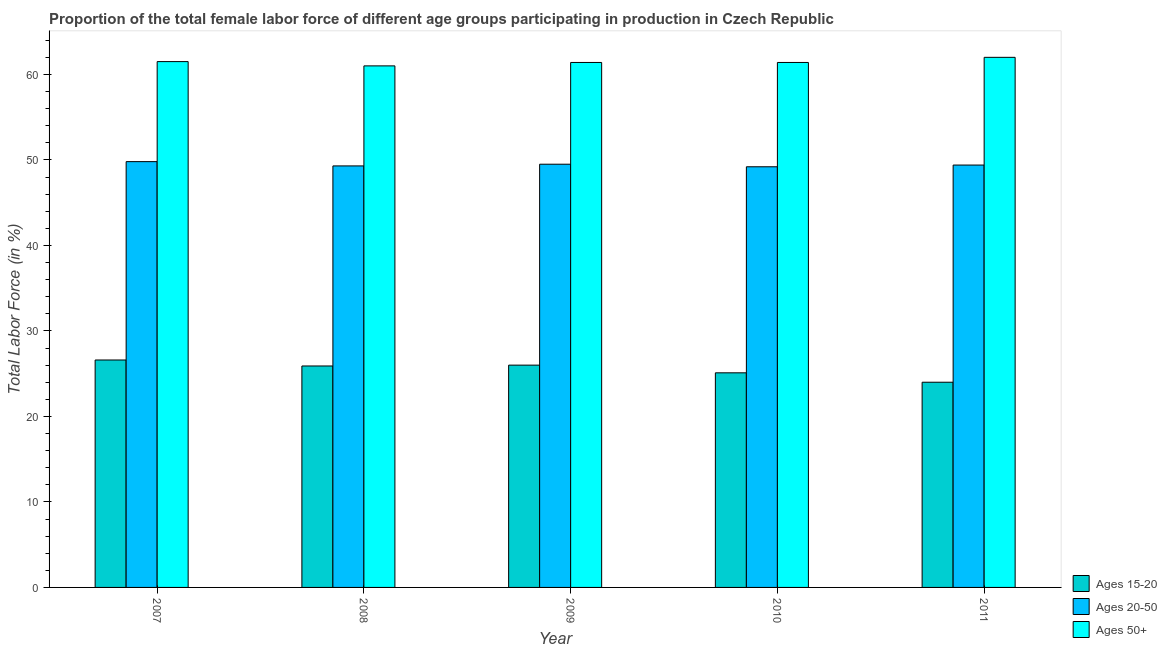How many different coloured bars are there?
Your response must be concise. 3. Are the number of bars per tick equal to the number of legend labels?
Ensure brevity in your answer.  Yes. What is the percentage of female labor force above age 50 in 2010?
Ensure brevity in your answer.  61.4. Across all years, what is the maximum percentage of female labor force above age 50?
Make the answer very short. 62. Across all years, what is the minimum percentage of female labor force above age 50?
Your answer should be very brief. 61. In which year was the percentage of female labor force within the age group 20-50 minimum?
Keep it short and to the point. 2010. What is the total percentage of female labor force within the age group 15-20 in the graph?
Provide a succinct answer. 127.6. What is the difference between the percentage of female labor force within the age group 20-50 in 2007 and the percentage of female labor force within the age group 15-20 in 2010?
Make the answer very short. 0.6. What is the average percentage of female labor force within the age group 15-20 per year?
Give a very brief answer. 25.52. In the year 2008, what is the difference between the percentage of female labor force within the age group 15-20 and percentage of female labor force within the age group 20-50?
Ensure brevity in your answer.  0. What is the ratio of the percentage of female labor force within the age group 15-20 in 2010 to that in 2011?
Make the answer very short. 1.05. Is the percentage of female labor force within the age group 15-20 in 2009 less than that in 2011?
Provide a short and direct response. No. What is the difference between the highest and the second highest percentage of female labor force within the age group 15-20?
Your answer should be very brief. 0.6. What is the difference between the highest and the lowest percentage of female labor force above age 50?
Provide a succinct answer. 1. In how many years, is the percentage of female labor force within the age group 15-20 greater than the average percentage of female labor force within the age group 15-20 taken over all years?
Give a very brief answer. 3. What does the 2nd bar from the left in 2008 represents?
Your answer should be compact. Ages 20-50. What does the 1st bar from the right in 2008 represents?
Offer a very short reply. Ages 50+. Is it the case that in every year, the sum of the percentage of female labor force within the age group 15-20 and percentage of female labor force within the age group 20-50 is greater than the percentage of female labor force above age 50?
Provide a succinct answer. Yes. How many bars are there?
Ensure brevity in your answer.  15. How are the legend labels stacked?
Your answer should be compact. Vertical. What is the title of the graph?
Your answer should be very brief. Proportion of the total female labor force of different age groups participating in production in Czech Republic. What is the label or title of the X-axis?
Make the answer very short. Year. What is the label or title of the Y-axis?
Offer a terse response. Total Labor Force (in %). What is the Total Labor Force (in %) in Ages 15-20 in 2007?
Provide a short and direct response. 26.6. What is the Total Labor Force (in %) of Ages 20-50 in 2007?
Your answer should be compact. 49.8. What is the Total Labor Force (in %) of Ages 50+ in 2007?
Offer a terse response. 61.5. What is the Total Labor Force (in %) of Ages 15-20 in 2008?
Offer a terse response. 25.9. What is the Total Labor Force (in %) of Ages 20-50 in 2008?
Your answer should be compact. 49.3. What is the Total Labor Force (in %) in Ages 15-20 in 2009?
Give a very brief answer. 26. What is the Total Labor Force (in %) of Ages 20-50 in 2009?
Offer a terse response. 49.5. What is the Total Labor Force (in %) in Ages 50+ in 2009?
Provide a succinct answer. 61.4. What is the Total Labor Force (in %) in Ages 15-20 in 2010?
Make the answer very short. 25.1. What is the Total Labor Force (in %) in Ages 20-50 in 2010?
Give a very brief answer. 49.2. What is the Total Labor Force (in %) of Ages 50+ in 2010?
Provide a short and direct response. 61.4. What is the Total Labor Force (in %) in Ages 15-20 in 2011?
Make the answer very short. 24. What is the Total Labor Force (in %) in Ages 20-50 in 2011?
Your answer should be compact. 49.4. What is the Total Labor Force (in %) in Ages 50+ in 2011?
Provide a short and direct response. 62. Across all years, what is the maximum Total Labor Force (in %) in Ages 15-20?
Make the answer very short. 26.6. Across all years, what is the maximum Total Labor Force (in %) in Ages 20-50?
Your answer should be very brief. 49.8. Across all years, what is the maximum Total Labor Force (in %) in Ages 50+?
Offer a terse response. 62. Across all years, what is the minimum Total Labor Force (in %) in Ages 15-20?
Keep it short and to the point. 24. Across all years, what is the minimum Total Labor Force (in %) in Ages 20-50?
Keep it short and to the point. 49.2. What is the total Total Labor Force (in %) of Ages 15-20 in the graph?
Keep it short and to the point. 127.6. What is the total Total Labor Force (in %) in Ages 20-50 in the graph?
Give a very brief answer. 247.2. What is the total Total Labor Force (in %) of Ages 50+ in the graph?
Your answer should be compact. 307.3. What is the difference between the Total Labor Force (in %) of Ages 15-20 in 2007 and that in 2008?
Provide a succinct answer. 0.7. What is the difference between the Total Labor Force (in %) of Ages 15-20 in 2007 and that in 2009?
Make the answer very short. 0.6. What is the difference between the Total Labor Force (in %) of Ages 15-20 in 2007 and that in 2010?
Your response must be concise. 1.5. What is the difference between the Total Labor Force (in %) of Ages 20-50 in 2007 and that in 2010?
Keep it short and to the point. 0.6. What is the difference between the Total Labor Force (in %) of Ages 50+ in 2007 and that in 2010?
Provide a succinct answer. 0.1. What is the difference between the Total Labor Force (in %) of Ages 50+ in 2008 and that in 2009?
Provide a succinct answer. -0.4. What is the difference between the Total Labor Force (in %) in Ages 50+ in 2008 and that in 2011?
Your response must be concise. -1. What is the difference between the Total Labor Force (in %) of Ages 15-20 in 2009 and that in 2010?
Provide a short and direct response. 0.9. What is the difference between the Total Labor Force (in %) of Ages 50+ in 2009 and that in 2010?
Your answer should be compact. 0. What is the difference between the Total Labor Force (in %) of Ages 20-50 in 2009 and that in 2011?
Your answer should be compact. 0.1. What is the difference between the Total Labor Force (in %) in Ages 50+ in 2009 and that in 2011?
Offer a terse response. -0.6. What is the difference between the Total Labor Force (in %) of Ages 15-20 in 2007 and the Total Labor Force (in %) of Ages 20-50 in 2008?
Give a very brief answer. -22.7. What is the difference between the Total Labor Force (in %) of Ages 15-20 in 2007 and the Total Labor Force (in %) of Ages 50+ in 2008?
Your answer should be very brief. -34.4. What is the difference between the Total Labor Force (in %) of Ages 15-20 in 2007 and the Total Labor Force (in %) of Ages 20-50 in 2009?
Ensure brevity in your answer.  -22.9. What is the difference between the Total Labor Force (in %) of Ages 15-20 in 2007 and the Total Labor Force (in %) of Ages 50+ in 2009?
Your answer should be compact. -34.8. What is the difference between the Total Labor Force (in %) of Ages 20-50 in 2007 and the Total Labor Force (in %) of Ages 50+ in 2009?
Keep it short and to the point. -11.6. What is the difference between the Total Labor Force (in %) in Ages 15-20 in 2007 and the Total Labor Force (in %) in Ages 20-50 in 2010?
Your response must be concise. -22.6. What is the difference between the Total Labor Force (in %) of Ages 15-20 in 2007 and the Total Labor Force (in %) of Ages 50+ in 2010?
Your answer should be very brief. -34.8. What is the difference between the Total Labor Force (in %) of Ages 20-50 in 2007 and the Total Labor Force (in %) of Ages 50+ in 2010?
Your response must be concise. -11.6. What is the difference between the Total Labor Force (in %) of Ages 15-20 in 2007 and the Total Labor Force (in %) of Ages 20-50 in 2011?
Your answer should be compact. -22.8. What is the difference between the Total Labor Force (in %) of Ages 15-20 in 2007 and the Total Labor Force (in %) of Ages 50+ in 2011?
Your answer should be compact. -35.4. What is the difference between the Total Labor Force (in %) in Ages 20-50 in 2007 and the Total Labor Force (in %) in Ages 50+ in 2011?
Your answer should be compact. -12.2. What is the difference between the Total Labor Force (in %) in Ages 15-20 in 2008 and the Total Labor Force (in %) in Ages 20-50 in 2009?
Your answer should be compact. -23.6. What is the difference between the Total Labor Force (in %) in Ages 15-20 in 2008 and the Total Labor Force (in %) in Ages 50+ in 2009?
Ensure brevity in your answer.  -35.5. What is the difference between the Total Labor Force (in %) in Ages 15-20 in 2008 and the Total Labor Force (in %) in Ages 20-50 in 2010?
Provide a succinct answer. -23.3. What is the difference between the Total Labor Force (in %) of Ages 15-20 in 2008 and the Total Labor Force (in %) of Ages 50+ in 2010?
Provide a short and direct response. -35.5. What is the difference between the Total Labor Force (in %) of Ages 15-20 in 2008 and the Total Labor Force (in %) of Ages 20-50 in 2011?
Your answer should be compact. -23.5. What is the difference between the Total Labor Force (in %) of Ages 15-20 in 2008 and the Total Labor Force (in %) of Ages 50+ in 2011?
Ensure brevity in your answer.  -36.1. What is the difference between the Total Labor Force (in %) of Ages 15-20 in 2009 and the Total Labor Force (in %) of Ages 20-50 in 2010?
Offer a terse response. -23.2. What is the difference between the Total Labor Force (in %) of Ages 15-20 in 2009 and the Total Labor Force (in %) of Ages 50+ in 2010?
Ensure brevity in your answer.  -35.4. What is the difference between the Total Labor Force (in %) in Ages 20-50 in 2009 and the Total Labor Force (in %) in Ages 50+ in 2010?
Offer a very short reply. -11.9. What is the difference between the Total Labor Force (in %) in Ages 15-20 in 2009 and the Total Labor Force (in %) in Ages 20-50 in 2011?
Your answer should be compact. -23.4. What is the difference between the Total Labor Force (in %) in Ages 15-20 in 2009 and the Total Labor Force (in %) in Ages 50+ in 2011?
Offer a terse response. -36. What is the difference between the Total Labor Force (in %) in Ages 15-20 in 2010 and the Total Labor Force (in %) in Ages 20-50 in 2011?
Make the answer very short. -24.3. What is the difference between the Total Labor Force (in %) of Ages 15-20 in 2010 and the Total Labor Force (in %) of Ages 50+ in 2011?
Give a very brief answer. -36.9. What is the average Total Labor Force (in %) of Ages 15-20 per year?
Ensure brevity in your answer.  25.52. What is the average Total Labor Force (in %) in Ages 20-50 per year?
Your response must be concise. 49.44. What is the average Total Labor Force (in %) of Ages 50+ per year?
Your answer should be very brief. 61.46. In the year 2007, what is the difference between the Total Labor Force (in %) in Ages 15-20 and Total Labor Force (in %) in Ages 20-50?
Offer a very short reply. -23.2. In the year 2007, what is the difference between the Total Labor Force (in %) of Ages 15-20 and Total Labor Force (in %) of Ages 50+?
Offer a very short reply. -34.9. In the year 2007, what is the difference between the Total Labor Force (in %) of Ages 20-50 and Total Labor Force (in %) of Ages 50+?
Make the answer very short. -11.7. In the year 2008, what is the difference between the Total Labor Force (in %) in Ages 15-20 and Total Labor Force (in %) in Ages 20-50?
Provide a short and direct response. -23.4. In the year 2008, what is the difference between the Total Labor Force (in %) of Ages 15-20 and Total Labor Force (in %) of Ages 50+?
Your response must be concise. -35.1. In the year 2009, what is the difference between the Total Labor Force (in %) in Ages 15-20 and Total Labor Force (in %) in Ages 20-50?
Your answer should be compact. -23.5. In the year 2009, what is the difference between the Total Labor Force (in %) in Ages 15-20 and Total Labor Force (in %) in Ages 50+?
Offer a very short reply. -35.4. In the year 2009, what is the difference between the Total Labor Force (in %) of Ages 20-50 and Total Labor Force (in %) of Ages 50+?
Your response must be concise. -11.9. In the year 2010, what is the difference between the Total Labor Force (in %) in Ages 15-20 and Total Labor Force (in %) in Ages 20-50?
Your answer should be very brief. -24.1. In the year 2010, what is the difference between the Total Labor Force (in %) of Ages 15-20 and Total Labor Force (in %) of Ages 50+?
Your answer should be compact. -36.3. In the year 2010, what is the difference between the Total Labor Force (in %) of Ages 20-50 and Total Labor Force (in %) of Ages 50+?
Keep it short and to the point. -12.2. In the year 2011, what is the difference between the Total Labor Force (in %) of Ages 15-20 and Total Labor Force (in %) of Ages 20-50?
Keep it short and to the point. -25.4. In the year 2011, what is the difference between the Total Labor Force (in %) of Ages 15-20 and Total Labor Force (in %) of Ages 50+?
Provide a succinct answer. -38. What is the ratio of the Total Labor Force (in %) in Ages 50+ in 2007 to that in 2008?
Offer a very short reply. 1.01. What is the ratio of the Total Labor Force (in %) in Ages 15-20 in 2007 to that in 2009?
Provide a short and direct response. 1.02. What is the ratio of the Total Labor Force (in %) of Ages 20-50 in 2007 to that in 2009?
Provide a succinct answer. 1.01. What is the ratio of the Total Labor Force (in %) in Ages 50+ in 2007 to that in 2009?
Your response must be concise. 1. What is the ratio of the Total Labor Force (in %) of Ages 15-20 in 2007 to that in 2010?
Give a very brief answer. 1.06. What is the ratio of the Total Labor Force (in %) of Ages 20-50 in 2007 to that in 2010?
Your answer should be compact. 1.01. What is the ratio of the Total Labor Force (in %) in Ages 50+ in 2007 to that in 2010?
Ensure brevity in your answer.  1. What is the ratio of the Total Labor Force (in %) of Ages 15-20 in 2007 to that in 2011?
Your response must be concise. 1.11. What is the ratio of the Total Labor Force (in %) of Ages 20-50 in 2008 to that in 2009?
Your response must be concise. 1. What is the ratio of the Total Labor Force (in %) of Ages 50+ in 2008 to that in 2009?
Offer a terse response. 0.99. What is the ratio of the Total Labor Force (in %) of Ages 15-20 in 2008 to that in 2010?
Make the answer very short. 1.03. What is the ratio of the Total Labor Force (in %) of Ages 20-50 in 2008 to that in 2010?
Your answer should be compact. 1. What is the ratio of the Total Labor Force (in %) of Ages 15-20 in 2008 to that in 2011?
Provide a short and direct response. 1.08. What is the ratio of the Total Labor Force (in %) of Ages 20-50 in 2008 to that in 2011?
Keep it short and to the point. 1. What is the ratio of the Total Labor Force (in %) of Ages 50+ in 2008 to that in 2011?
Offer a very short reply. 0.98. What is the ratio of the Total Labor Force (in %) in Ages 15-20 in 2009 to that in 2010?
Offer a very short reply. 1.04. What is the ratio of the Total Labor Force (in %) of Ages 50+ in 2009 to that in 2010?
Offer a very short reply. 1. What is the ratio of the Total Labor Force (in %) in Ages 20-50 in 2009 to that in 2011?
Provide a succinct answer. 1. What is the ratio of the Total Labor Force (in %) of Ages 50+ in 2009 to that in 2011?
Your answer should be very brief. 0.99. What is the ratio of the Total Labor Force (in %) of Ages 15-20 in 2010 to that in 2011?
Keep it short and to the point. 1.05. What is the ratio of the Total Labor Force (in %) of Ages 50+ in 2010 to that in 2011?
Your response must be concise. 0.99. What is the difference between the highest and the second highest Total Labor Force (in %) of Ages 15-20?
Provide a short and direct response. 0.6. What is the difference between the highest and the lowest Total Labor Force (in %) in Ages 15-20?
Your answer should be very brief. 2.6. What is the difference between the highest and the lowest Total Labor Force (in %) of Ages 50+?
Offer a terse response. 1. 